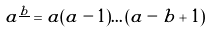Convert formula to latex. <formula><loc_0><loc_0><loc_500><loc_500>a ^ { \underline { b } } = a ( a - 1 ) \dots ( a - b + 1 )</formula> 